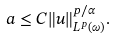Convert formula to latex. <formula><loc_0><loc_0><loc_500><loc_500>a \leq C \| u \| ^ { p / \alpha } _ { L ^ { p } ( \omega ) } .</formula> 